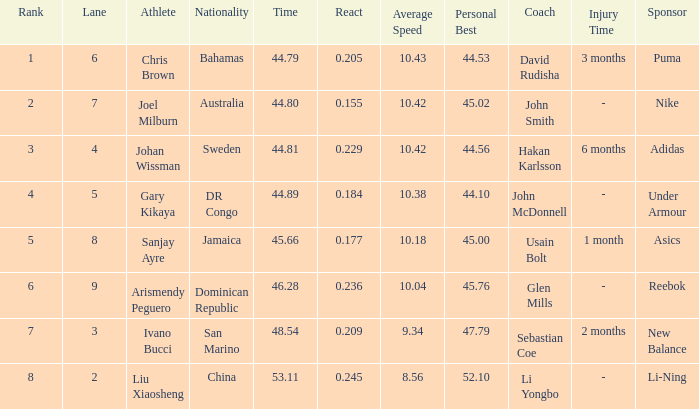Could you parse the entire table as a dict? {'header': ['Rank', 'Lane', 'Athlete', 'Nationality', 'Time', 'React', 'Average Speed', 'Personal Best', 'Coach', 'Injury Time', 'Sponsor'], 'rows': [['1', '6', 'Chris Brown', 'Bahamas', '44.79', '0.205', '10.43', '44.53', 'David Rudisha', '3 months', 'Puma'], ['2', '7', 'Joel Milburn', 'Australia', '44.80', '0.155', '10.42', '45.02', 'John Smith', '-', 'Nike'], ['3', '4', 'Johan Wissman', 'Sweden', '44.81', '0.229', '10.42', '44.56', 'Hakan Karlsson', '6 months', 'Adidas'], ['4', '5', 'Gary Kikaya', 'DR Congo', '44.89', '0.184', '10.38', '44.10', 'John McDonnell', '-', 'Under Armour'], ['5', '8', 'Sanjay Ayre', 'Jamaica', '45.66', '0.177', '10.18', '45.00', 'Usain Bolt', '1 month', 'Asics'], ['6', '9', 'Arismendy Peguero', 'Dominican Republic', '46.28', '0.236', '10.04', '45.76', 'Glen Mills', '-', 'Reebok'], ['7', '3', 'Ivano Bucci', 'San Marino', '48.54', '0.209', '9.34', '47.79', 'Sebastian Coe', '2 months', 'New Balance'], ['8', '2', 'Liu Xiaosheng', 'China', '53.11', '0.245', '8.56', '52.10', 'Li Yongbo', '-', 'Li-Ning']]} What Lane has a 0.209 React entered with a Rank entry that is larger than 6? 2.0. 